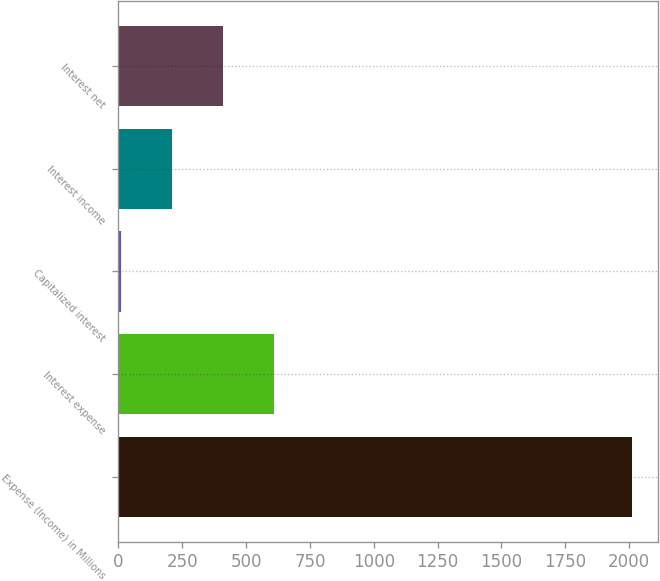Convert chart. <chart><loc_0><loc_0><loc_500><loc_500><bar_chart><fcel>Expense (Income) in Millions<fcel>Interest expense<fcel>Capitalized interest<fcel>Interest income<fcel>Interest net<nl><fcel>2012<fcel>609.83<fcel>8.9<fcel>209.21<fcel>409.52<nl></chart> 